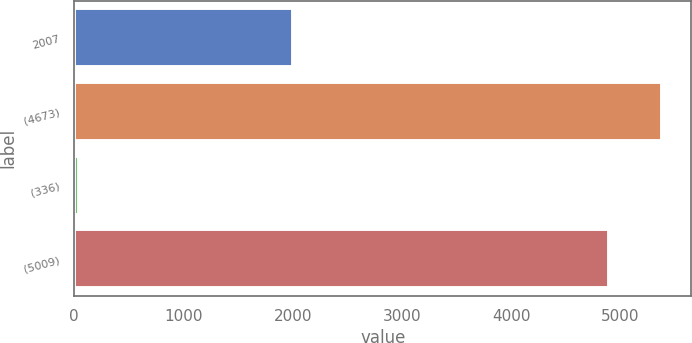<chart> <loc_0><loc_0><loc_500><loc_500><bar_chart><fcel>2007<fcel>(4673)<fcel>(336)<fcel>(5009)<nl><fcel>2005<fcel>5381.2<fcel>45<fcel>4892<nl></chart> 